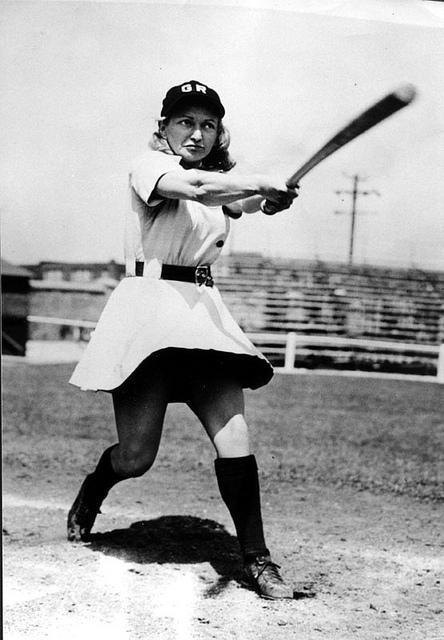How many toy mice have a sign?
Give a very brief answer. 0. 